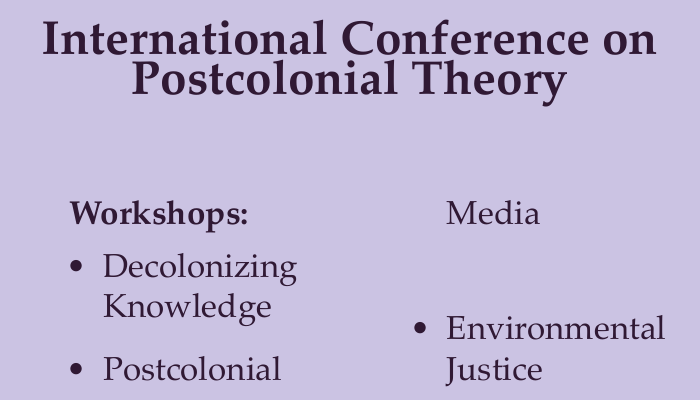What are the titles of the workshops? The titles of the workshops are listed under the "Workshops:" section of the document.
Answer: Decolonizing Knowledge, Postcolonial Media, Environmental Justice How can one join the conference? The ways to join the conference are mentioned in the "Join us:" section.
Answer: Conference website, Mobile app, Conference portal What color scheme is used in the document? The document uses specific color definitions for text and background.
Answer: Dark purple and light purple What is the main theme of the conference? The main theme is stated clearly at the top of the document.
Answer: Postcolonial Theory How many workshops are listed in the document? The total number of workshops can be counted from the bulleted list.
Answer: Three 